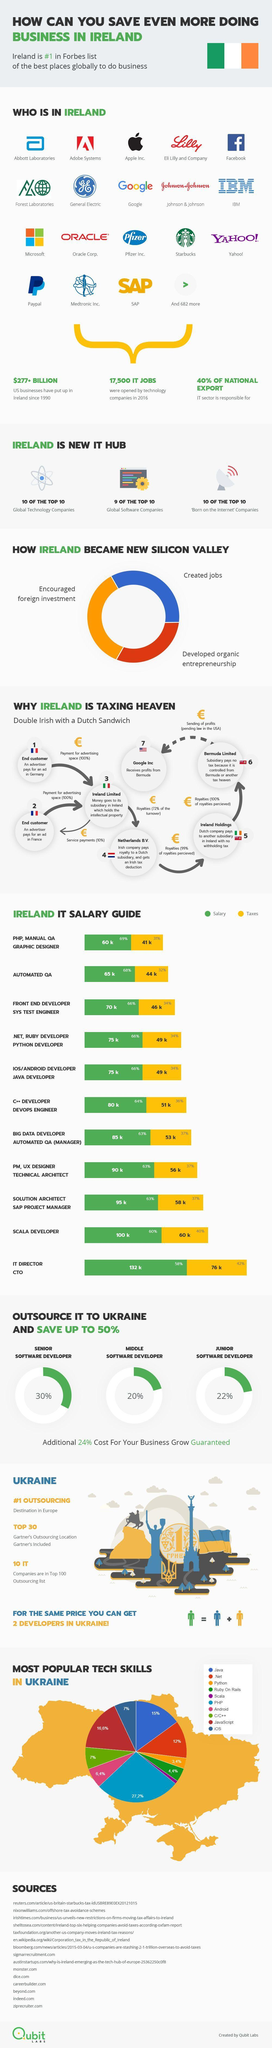What percentage of National Export is not from the IT sector in Ireland?
Answer the question with a short phrase. 60% What is the amount of salary offered for an Automated QA job in Ireland? 65k What is the amount of salary offered for a C++ Developer/Devops Engineer job in Ireland? 80k What is the amount of tax imposed on the salary of a Scala developer in Ireland? 60k What is the amount of tax imposed on the salary of a IT director/CTO in Ireland? 76k Which IT job profile offers a salary package of 65k in Ireland? Automated QA Which is the least  popular tech skill in Ukraine? Scala Which is the most popular tech skill in Ukraine? PHP What is the  amount of money invested by the US businesses in Ireland since 1990? $277+ BILLION Which IT job profile offers a salary package of 100k in Ireland? Scala Developer 